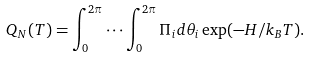Convert formula to latex. <formula><loc_0><loc_0><loc_500><loc_500>Q _ { N } ( T ) = \int _ { 0 } ^ { 2 \pi } \cdots \int _ { 0 } ^ { 2 \pi } \Pi _ { i } d \theta _ { i } \exp ( - H / k _ { B } T ) .</formula> 